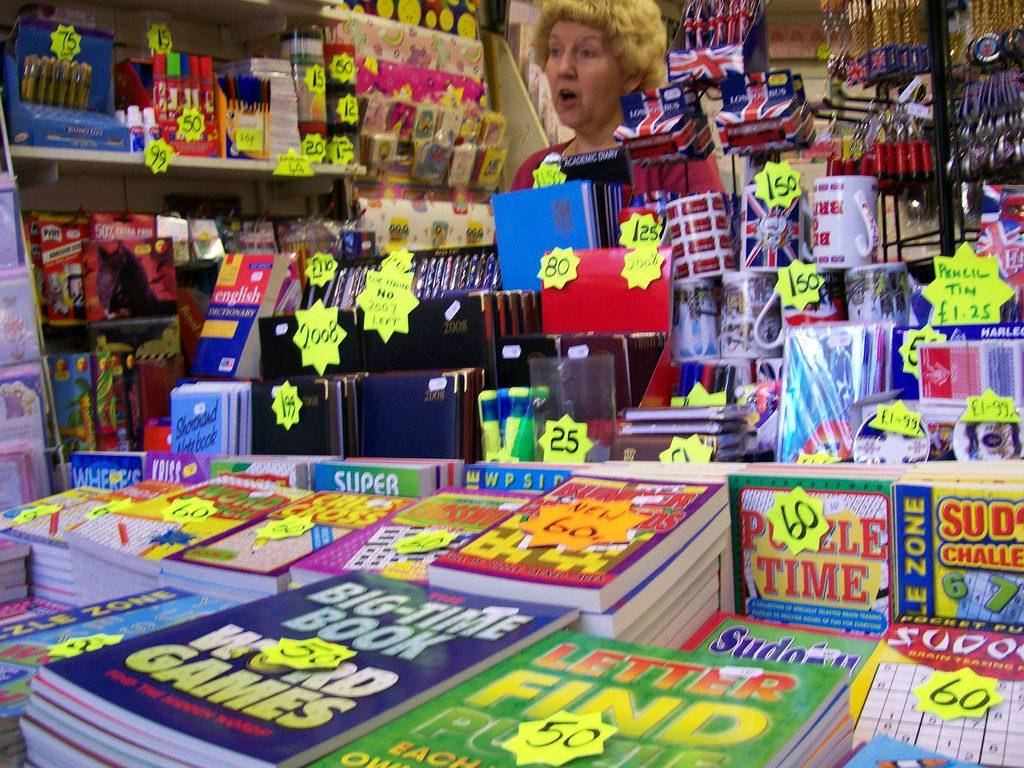<image>
Give a short and clear explanation of the subsequent image. A Big-Time Book of word games sits stacked with several other game and puzzle books in a store. 